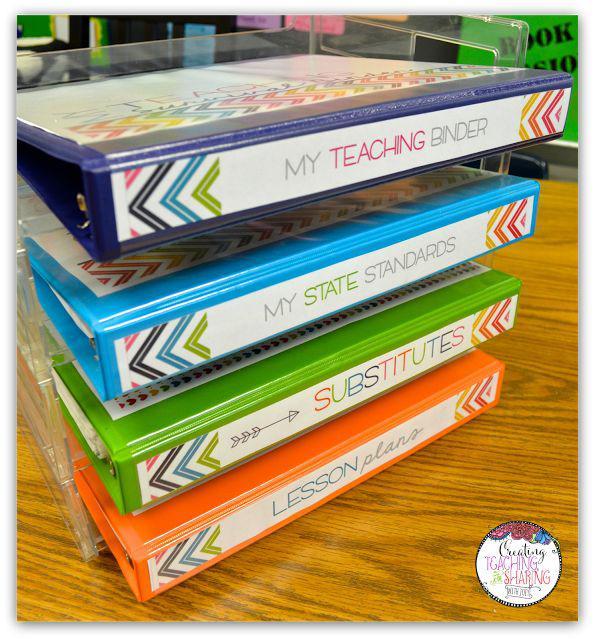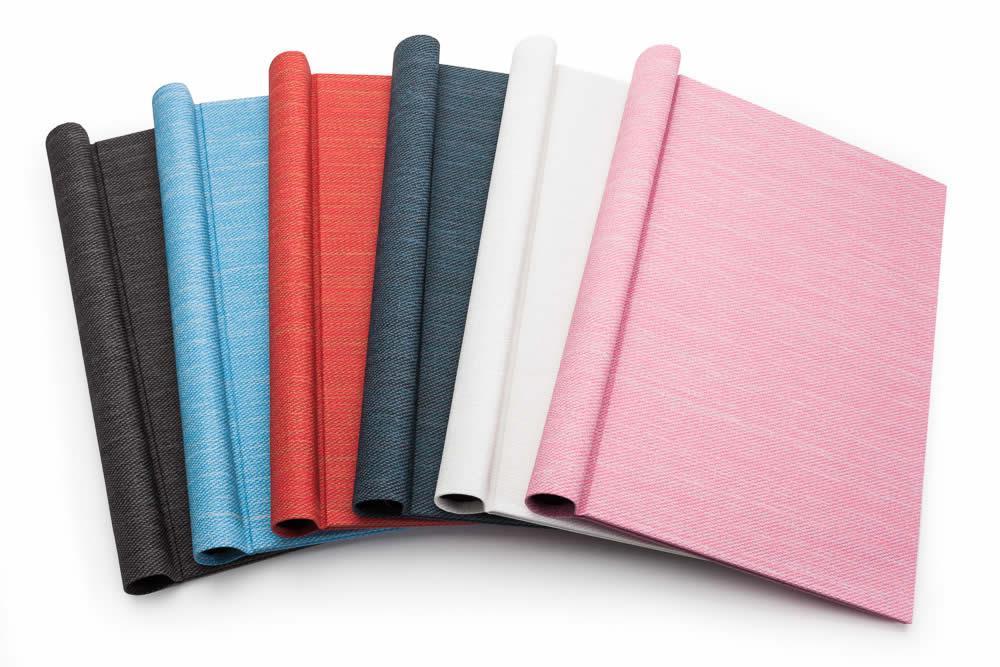The first image is the image on the left, the second image is the image on the right. Examine the images to the left and right. Is the description "One image shows overlapping binders of different solid colors arranged in a single curved, arching line." accurate? Answer yes or no. Yes. 